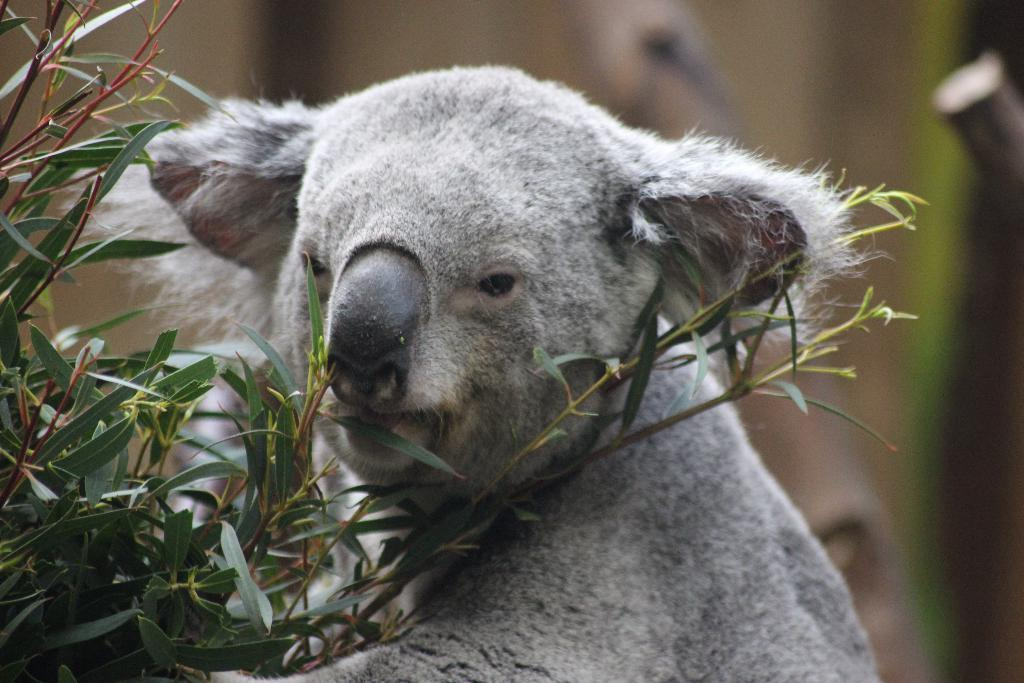What type of creature is present in the image? There is an animal in the image. Can you describe the animal's location in relation to the plant? The animal is behind a plant with leaves. What can be said about the background of the image? The background of the image is blurry. What color are the nails on the animal's paws in the image? There are no nails or paws mentioned in the image, as it only states that there is an animal behind a plant with leaves. 